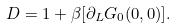<formula> <loc_0><loc_0><loc_500><loc_500>D = 1 + \beta [ \partial _ { L } G _ { 0 } ( 0 , 0 ) ] .</formula> 